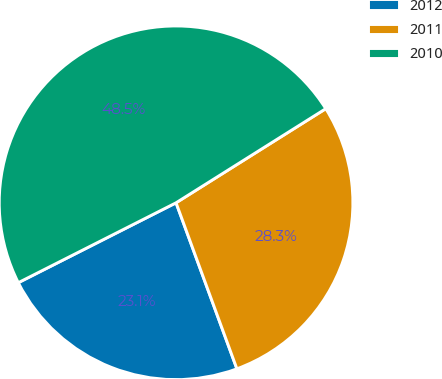<chart> <loc_0><loc_0><loc_500><loc_500><pie_chart><fcel>2012<fcel>2011<fcel>2010<nl><fcel>23.13%<fcel>28.34%<fcel>48.53%<nl></chart> 